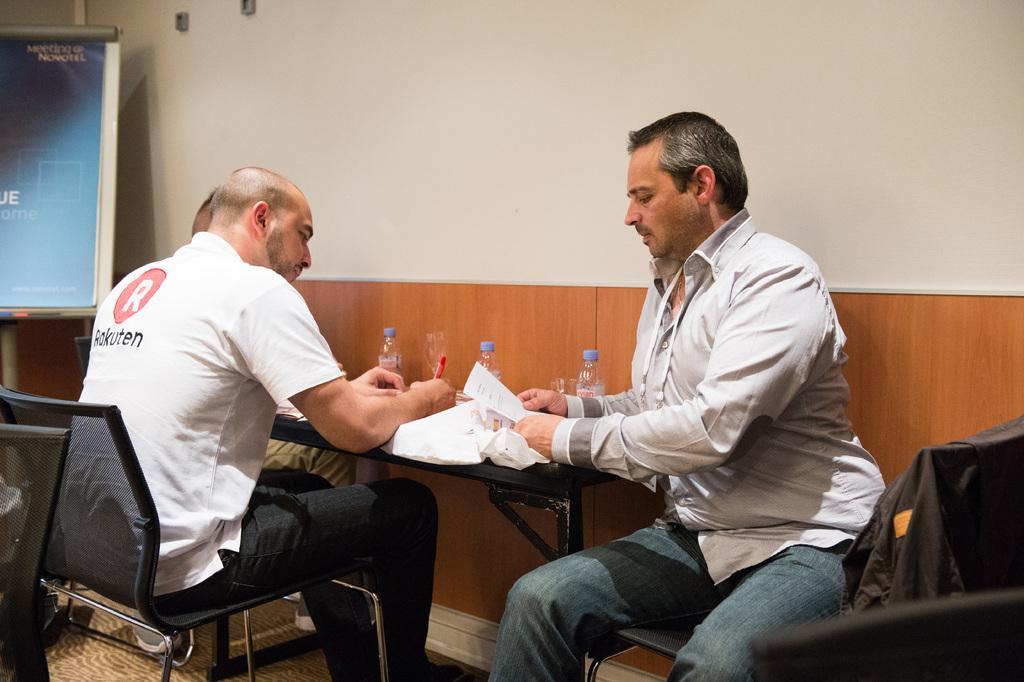Could you give a brief overview of what you see in this image? This image is clicked in a room. There are chairs,table ,board and people in this image. People are sitting on chairs around the table. Table have water bottles ,papers on that. And that board consists of some papers. 